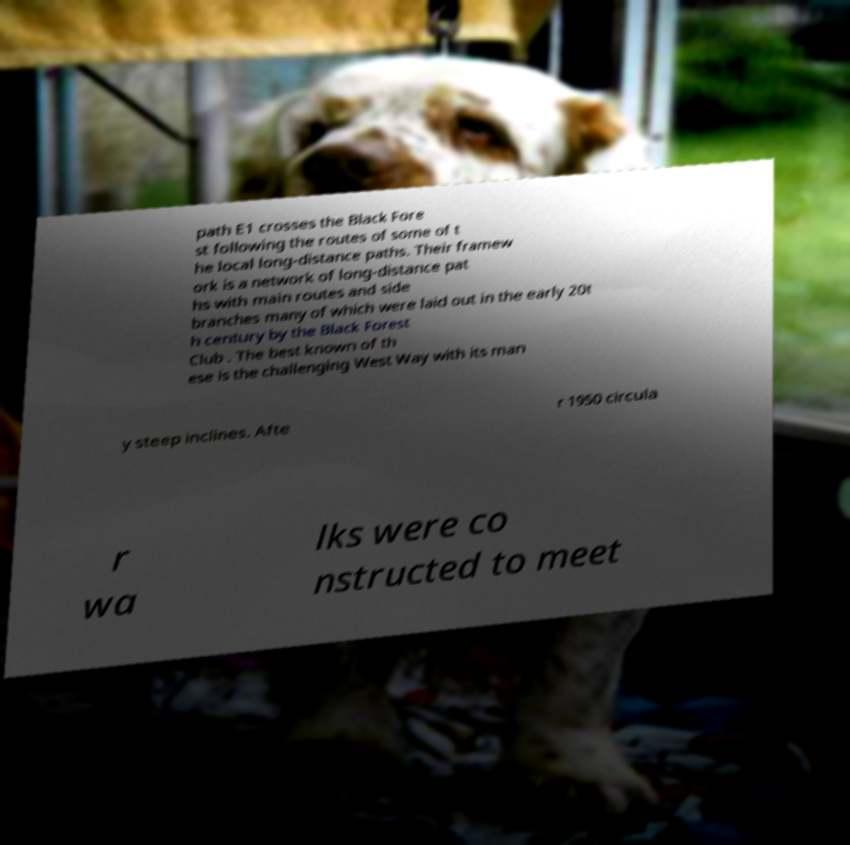For documentation purposes, I need the text within this image transcribed. Could you provide that? path E1 crosses the Black Fore st following the routes of some of t he local long-distance paths. Their framew ork is a network of long-distance pat hs with main routes and side branches many of which were laid out in the early 20t h century by the Black Forest Club . The best known of th ese is the challenging West Way with its man y steep inclines. Afte r 1950 circula r wa lks were co nstructed to meet 